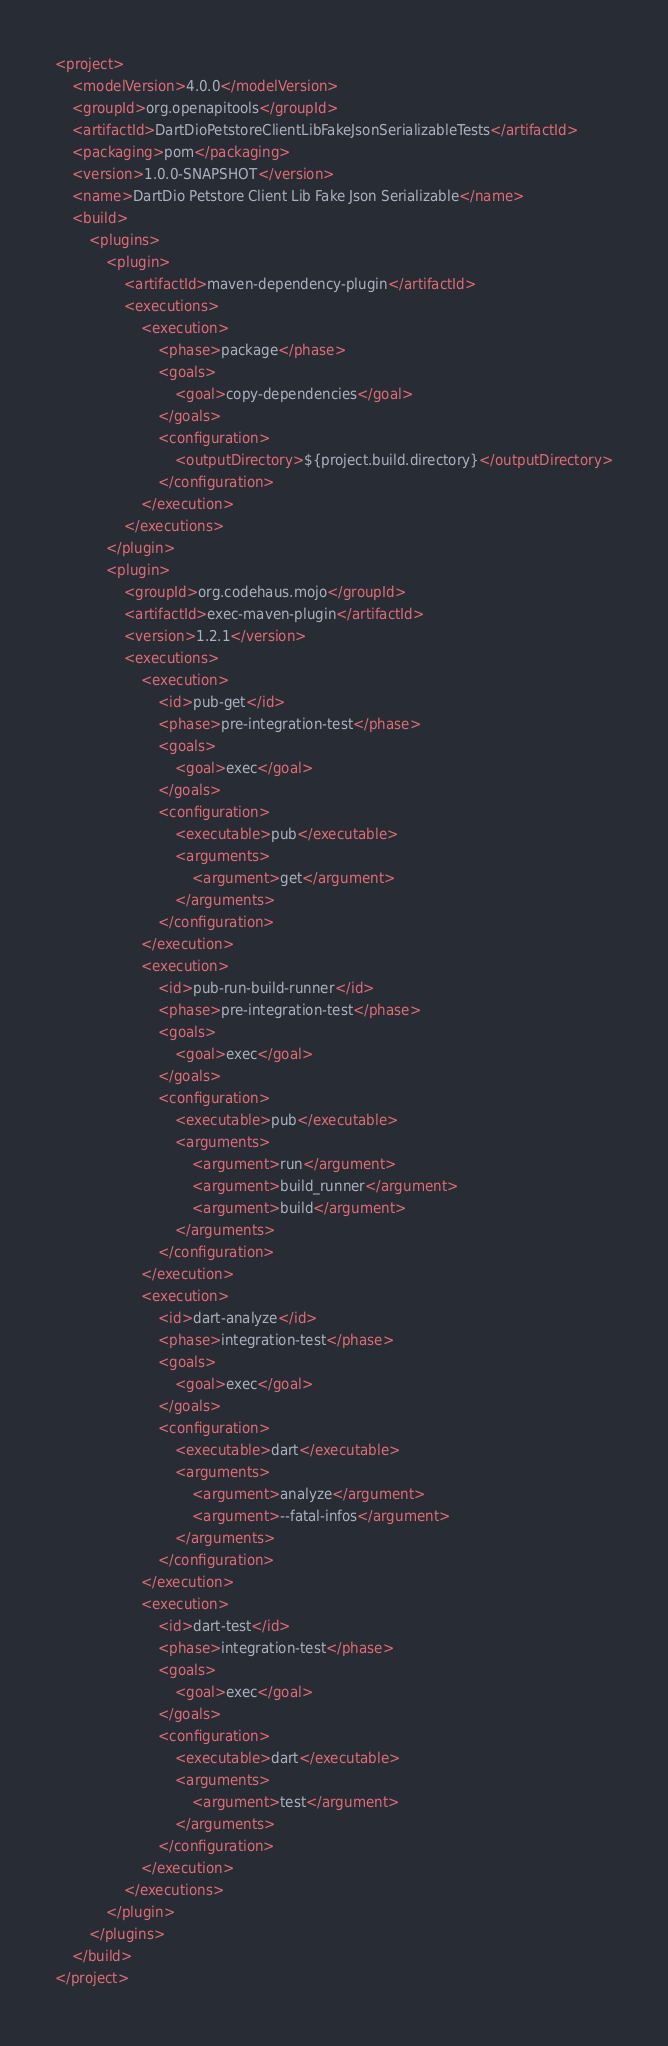Convert code to text. <code><loc_0><loc_0><loc_500><loc_500><_XML_><project>
    <modelVersion>4.0.0</modelVersion>
    <groupId>org.openapitools</groupId>
    <artifactId>DartDioPetstoreClientLibFakeJsonSerializableTests</artifactId>
    <packaging>pom</packaging>
    <version>1.0.0-SNAPSHOT</version>
    <name>DartDio Petstore Client Lib Fake Json Serializable</name>
    <build>
        <plugins>
            <plugin>
                <artifactId>maven-dependency-plugin</artifactId>
                <executions>
                    <execution>
                        <phase>package</phase>
                        <goals>
                            <goal>copy-dependencies</goal>
                        </goals>
                        <configuration>
                            <outputDirectory>${project.build.directory}</outputDirectory>
                        </configuration>
                    </execution>
                </executions>
            </plugin>
            <plugin>
                <groupId>org.codehaus.mojo</groupId>
                <artifactId>exec-maven-plugin</artifactId>
                <version>1.2.1</version>
                <executions>
                    <execution>
                        <id>pub-get</id>
                        <phase>pre-integration-test</phase>
                        <goals>
                            <goal>exec</goal>
                        </goals>
                        <configuration>
                            <executable>pub</executable>
                            <arguments>
                                <argument>get</argument>
                            </arguments>
                        </configuration>
                    </execution>
                    <execution>
                        <id>pub-run-build-runner</id>
                        <phase>pre-integration-test</phase>
                        <goals>
                            <goal>exec</goal>
                        </goals>
                        <configuration>
                            <executable>pub</executable>
                            <arguments>
                                <argument>run</argument>
                                <argument>build_runner</argument>
                                <argument>build</argument>
                            </arguments>
                        </configuration>
                    </execution>
                    <execution>
                        <id>dart-analyze</id>
                        <phase>integration-test</phase>
                        <goals>
                            <goal>exec</goal>
                        </goals>
                        <configuration>
                            <executable>dart</executable>
                            <arguments>
                                <argument>analyze</argument>
                                <argument>--fatal-infos</argument>
                            </arguments>
                        </configuration>
                    </execution>
                    <execution>
                        <id>dart-test</id>
                        <phase>integration-test</phase>
                        <goals>
                            <goal>exec</goal>
                        </goals>
                        <configuration>
                            <executable>dart</executable>
                            <arguments>
                                <argument>test</argument>
                            </arguments>
                        </configuration>
                    </execution>
                </executions>
            </plugin>
        </plugins>
    </build>
</project>
</code> 